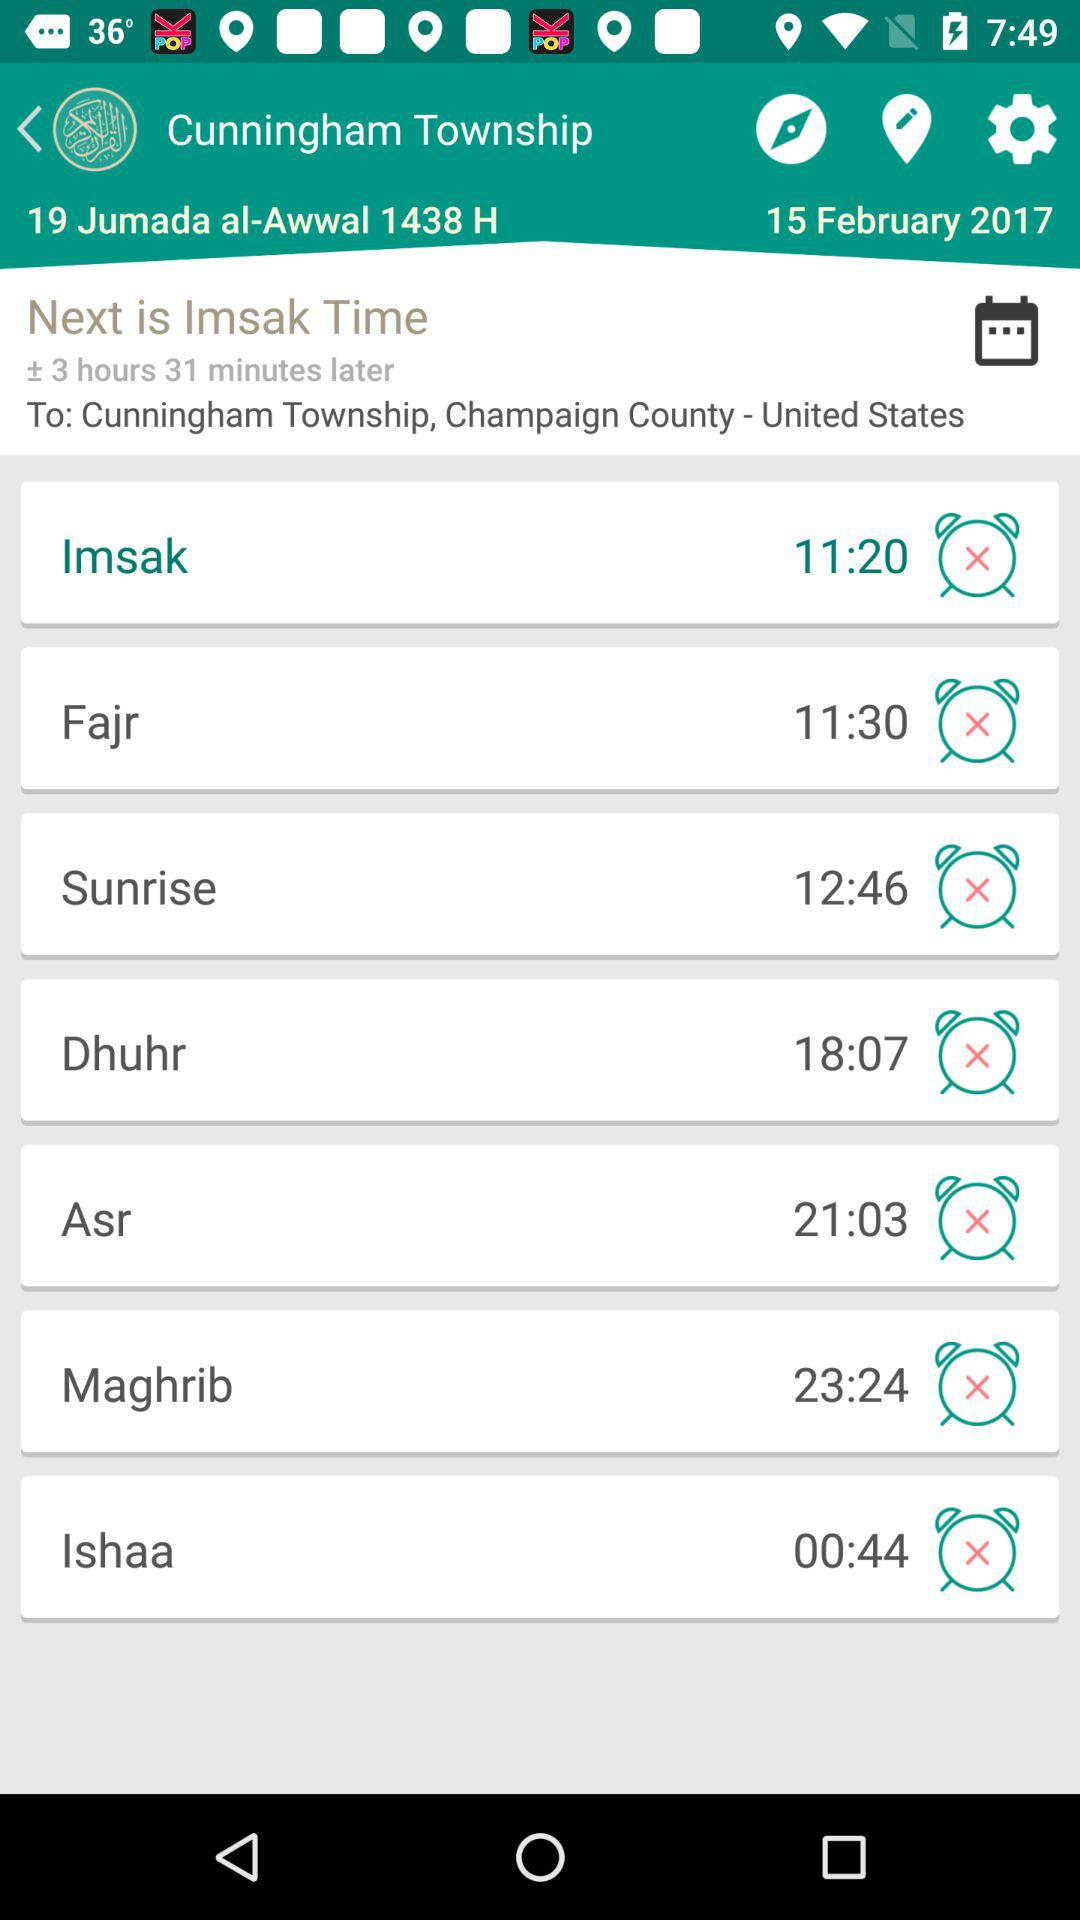Which prayer is at 4:44 AM?
When the provided information is insufficient, respond with <no answer>. <no answer> 